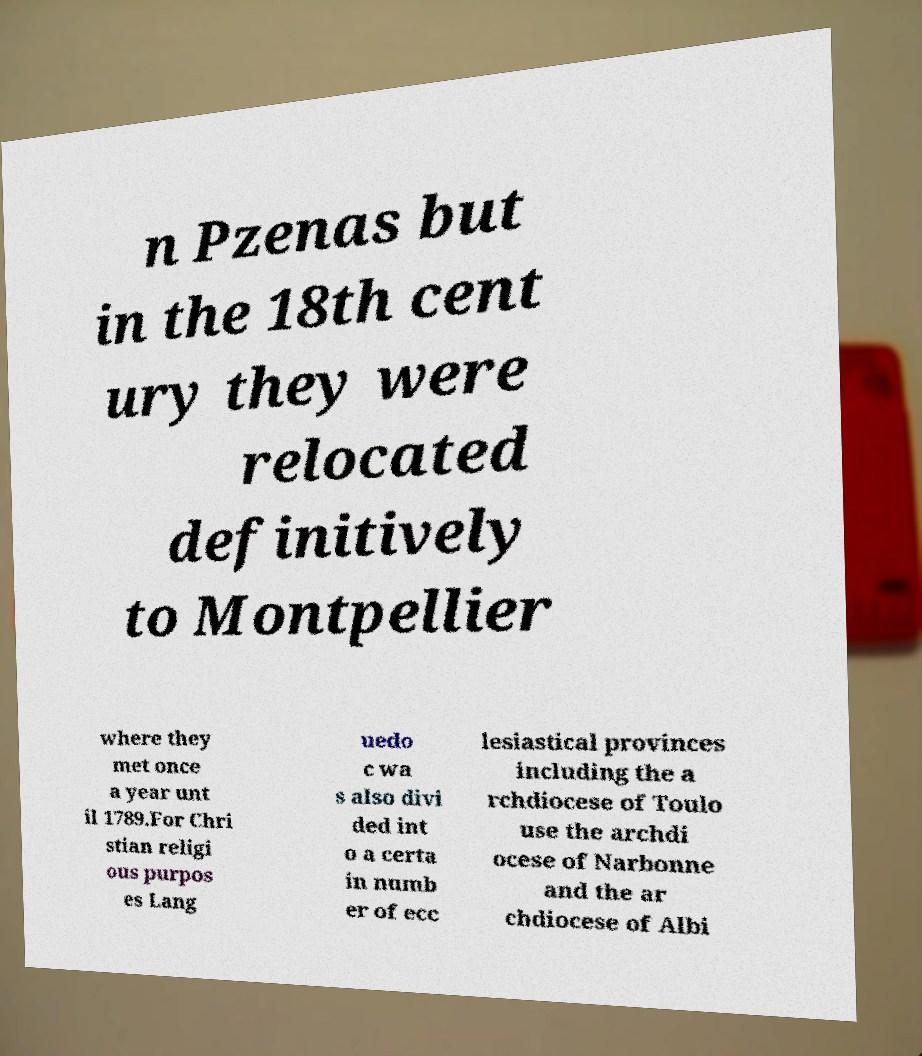Could you assist in decoding the text presented in this image and type it out clearly? n Pzenas but in the 18th cent ury they were relocated definitively to Montpellier where they met once a year unt il 1789.For Chri stian religi ous purpos es Lang uedo c wa s also divi ded int o a certa in numb er of ecc lesiastical provinces including the a rchdiocese of Toulo use the archdi ocese of Narbonne and the ar chdiocese of Albi 